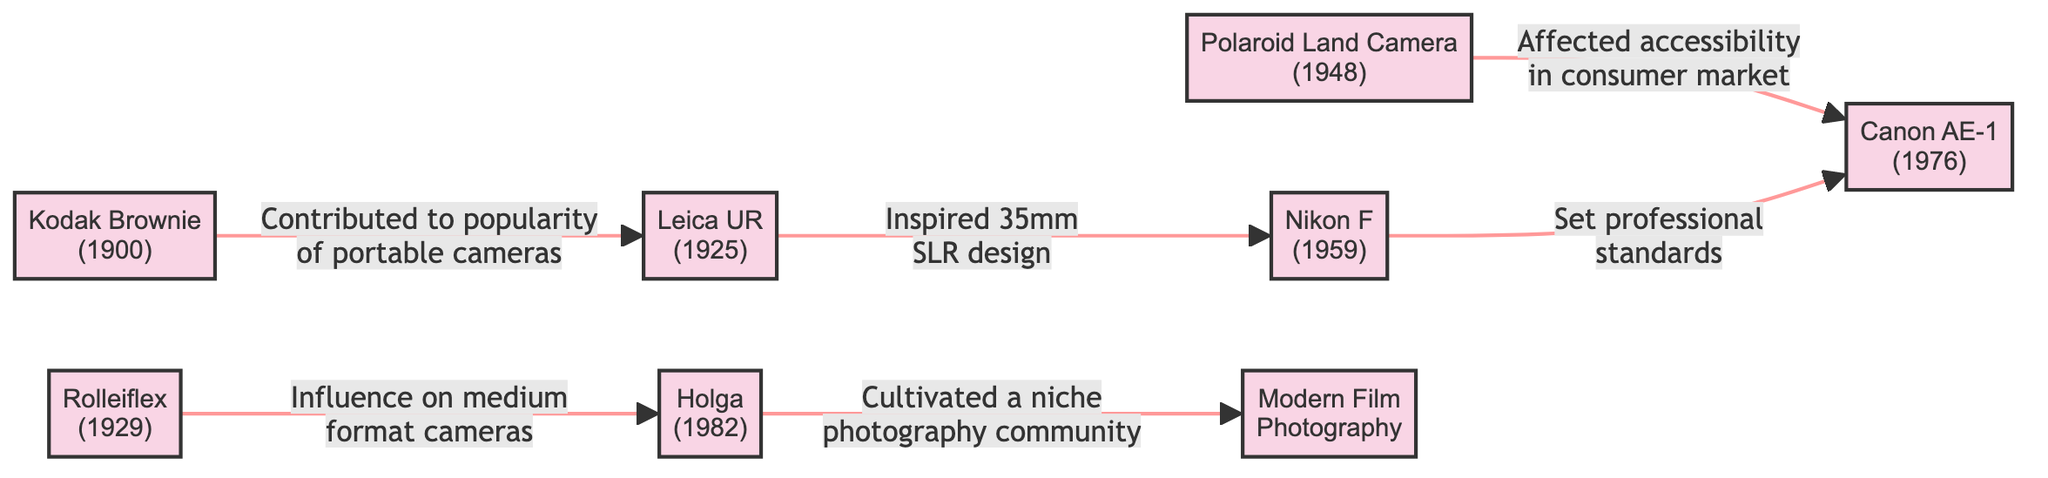What is the earliest camera listed in the diagram? The earliest camera mentioned in the diagram is the Kodak Brownie, which was released in 1900. This can be identified as it is the first node in the flowchart labeled with both the camera name and its year.
Answer: Kodak Brownie How many cameras are shown in the diagram? There are eight cameras displayed in the diagram, which can be counted by identifying each distinct node present, from the Kodak Brownie to the Modern Film Photography node.
Answer: 8 Which camera influenced medium format cameras? The camera that influenced medium format cameras is the Rolleiflex, as indicated by the directed edge pointing from Rolleiflex to Holga with the respective description.
Answer: Rolleiflex What relationship exists between the Leica UR and the Nikon F? The relationship between the Leica UR and the Nikon F is that the Leica UR inspired 35mm SLR design, which is depicted by the directed edge that connects them, along with the descriptive label.
Answer: Inspired 35mm SLR design Which camera affected accessibility in the consumer market? The camera that affected accessibility in the consumer market is the Polaroid Land Camera. This information is presented in the diagram by a directed edge leading to the Canon AE-1, marked with the relevant description.
Answer: Polaroid Land Camera How did the Nikon F impact professional photography? The Nikon F set professional standards in photography, as indicated by the descriptive text accompanying the edge that connects it to the Canon AE-1, denoting its influence on professional practices.
Answer: Set professional standards Which camera cultivated a niche photography community? The camera that cultivated a niche photography community is the Holga, based on the connection it shares with the Modern Film Photography node, described explicitly in the diagram.
Answer: Holga What is the relationship between the Polaroid Land Camera and the Canon AE-1? The Polaroid Land Camera affected accessibility in the consumer market, leading to the Canon AE-1, illustrating how it improved the availability of photography tools for consumers.
Answer: Affected accessibility in consumer market What impact did the Kodak Brownie have on the development of later cameras? The Kodak Brownie contributed to the popularity of portable cameras, which can be traced through the flow from Kodak Brownie to Leica UR, highlighting its significant role in shaping camera design and usage.
Answer: Contributed to popularity of portable cameras 